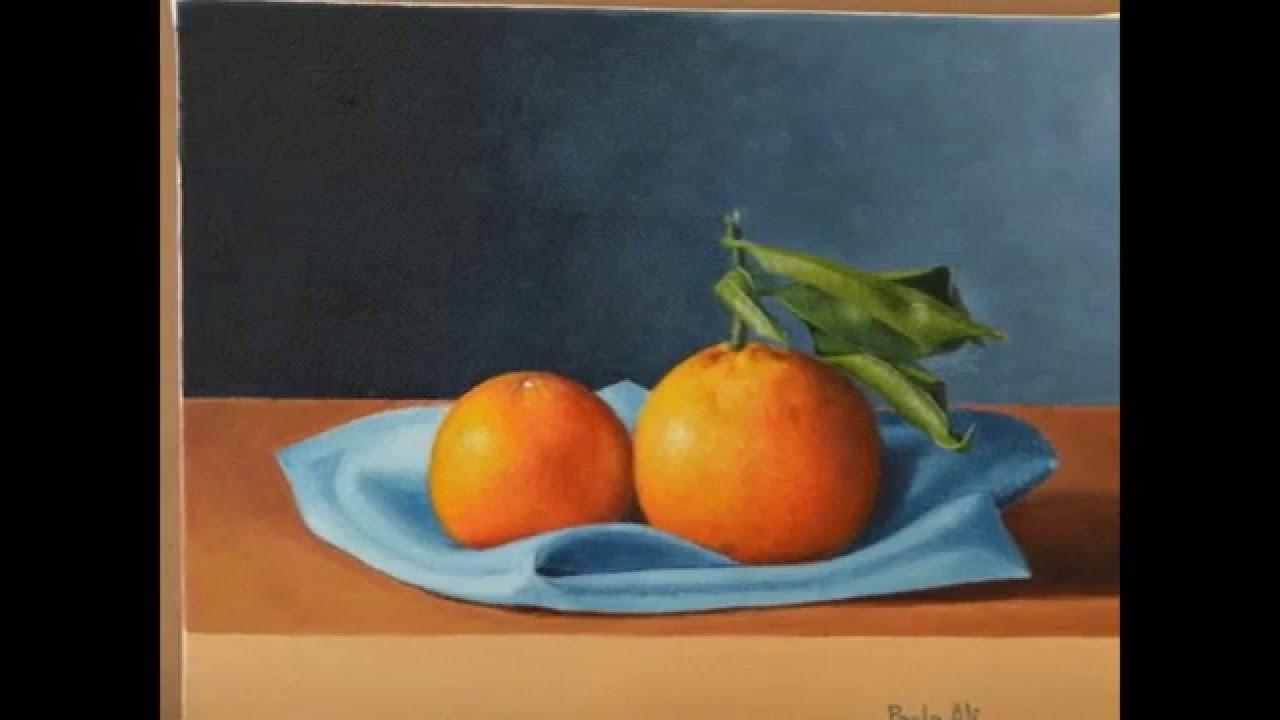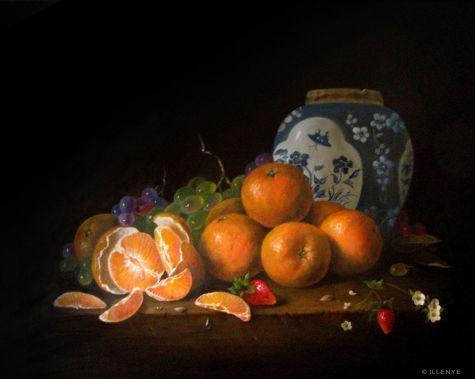The first image is the image on the left, the second image is the image on the right. Considering the images on both sides, is "One image shows a peeled orange with its peel loosely around it, in front of a bunch of grapes." valid? Answer yes or no. Yes. The first image is the image on the left, the second image is the image on the right. For the images shown, is this caption "In at least on of the images, bunches of grapes are sitting on a table near some oranges." true? Answer yes or no. Yes. 